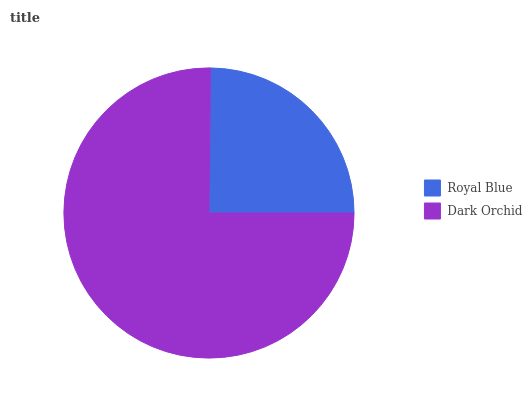Is Royal Blue the minimum?
Answer yes or no. Yes. Is Dark Orchid the maximum?
Answer yes or no. Yes. Is Dark Orchid the minimum?
Answer yes or no. No. Is Dark Orchid greater than Royal Blue?
Answer yes or no. Yes. Is Royal Blue less than Dark Orchid?
Answer yes or no. Yes. Is Royal Blue greater than Dark Orchid?
Answer yes or no. No. Is Dark Orchid less than Royal Blue?
Answer yes or no. No. Is Dark Orchid the high median?
Answer yes or no. Yes. Is Royal Blue the low median?
Answer yes or no. Yes. Is Royal Blue the high median?
Answer yes or no. No. Is Dark Orchid the low median?
Answer yes or no. No. 